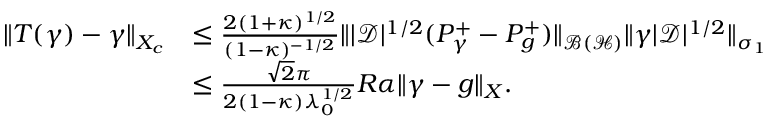Convert formula to latex. <formula><loc_0><loc_0><loc_500><loc_500>\begin{array} { r l } { \| T ( \gamma ) - \gamma \| _ { X _ { c } } } & { \leq \frac { 2 ( 1 + \kappa ) ^ { 1 / 2 } } { ( 1 - \kappa ) ^ { - 1 / 2 } } \| | \mathcal { D } | ^ { 1 / 2 } ( P _ { \gamma } ^ { + } - P _ { g } ^ { + } ) \| _ { \mathcal { B } ( \mathcal { H } ) } \| \gamma | \mathcal { D } | ^ { 1 / 2 } \| _ { \sigma _ { 1 } } } \\ & { \leq \frac { \sqrt { 2 } \pi } { 2 ( 1 - \kappa ) \lambda _ { 0 } ^ { 1 / 2 } } R \alpha \| \gamma - g \| _ { X } . } \end{array}</formula> 